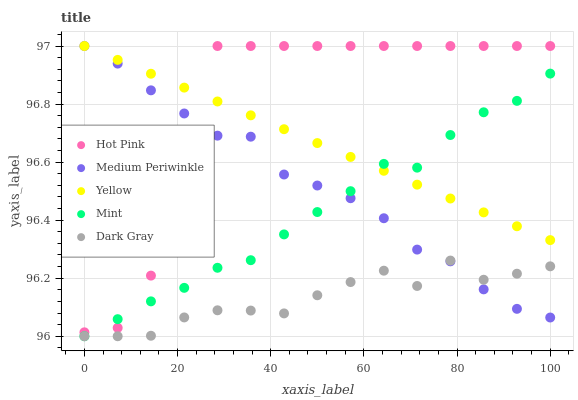Does Dark Gray have the minimum area under the curve?
Answer yes or no. Yes. Does Hot Pink have the maximum area under the curve?
Answer yes or no. Yes. Does Mint have the minimum area under the curve?
Answer yes or no. No. Does Mint have the maximum area under the curve?
Answer yes or no. No. Is Yellow the smoothest?
Answer yes or no. Yes. Is Hot Pink the roughest?
Answer yes or no. Yes. Is Mint the smoothest?
Answer yes or no. No. Is Mint the roughest?
Answer yes or no. No. Does Dark Gray have the lowest value?
Answer yes or no. Yes. Does Hot Pink have the lowest value?
Answer yes or no. No. Does Yellow have the highest value?
Answer yes or no. Yes. Does Mint have the highest value?
Answer yes or no. No. Is Dark Gray less than Yellow?
Answer yes or no. Yes. Is Yellow greater than Dark Gray?
Answer yes or no. Yes. Does Hot Pink intersect Mint?
Answer yes or no. Yes. Is Hot Pink less than Mint?
Answer yes or no. No. Is Hot Pink greater than Mint?
Answer yes or no. No. Does Dark Gray intersect Yellow?
Answer yes or no. No. 